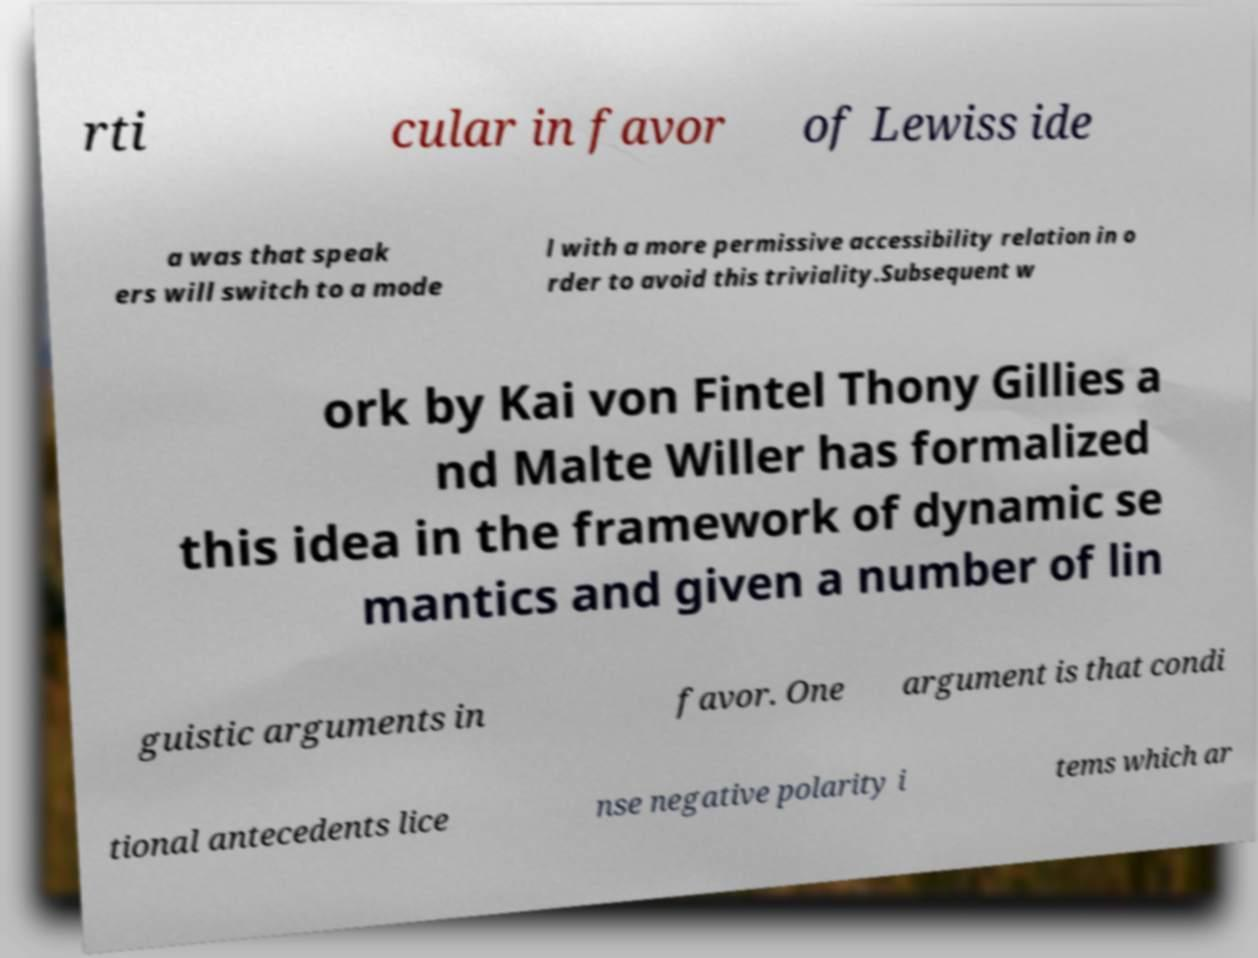For documentation purposes, I need the text within this image transcribed. Could you provide that? rti cular in favor of Lewiss ide a was that speak ers will switch to a mode l with a more permissive accessibility relation in o rder to avoid this triviality.Subsequent w ork by Kai von Fintel Thony Gillies a nd Malte Willer has formalized this idea in the framework of dynamic se mantics and given a number of lin guistic arguments in favor. One argument is that condi tional antecedents lice nse negative polarity i tems which ar 